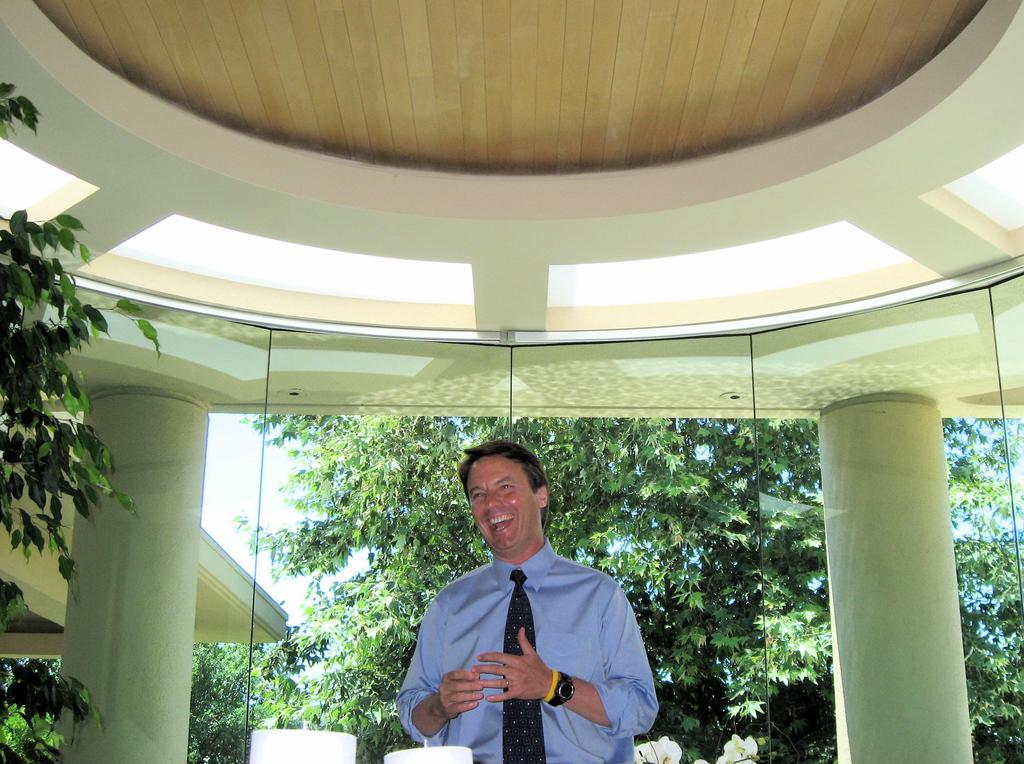What is the main subject of the image? There is a man standing in the center of the image. What is the man's facial expression? The man is smiling. What can be seen in the background of the image? There are pillars, trees, and the sky visible in the background of the image. What architectural feature is present at the top of the image? There is a roof at the top of the image. What arithmetic problem is the man solving in the image? There is no indication in the image that the man is solving an arithmetic problem. What is the weight of the man's tongue in the image? There is no information about the man's tongue in the image, so it is impossible to determine its weight. 